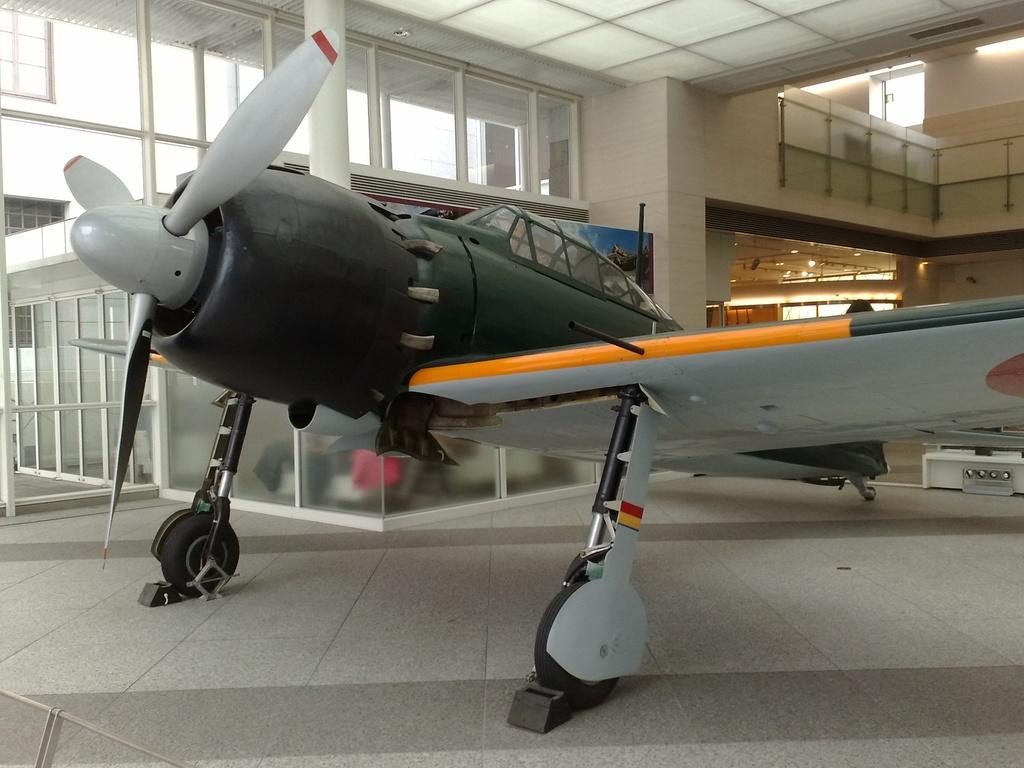What is the main subject of the image? The main subject of the image is a flight. Where is the flight located? The flight is inside a compartment. What can be seen behind the flight? There are many windows behind the flight. Can you see a person crushing a worm in the image? There is no person or worm present in the image; it only features a flight inside a compartment with windows behind it. 